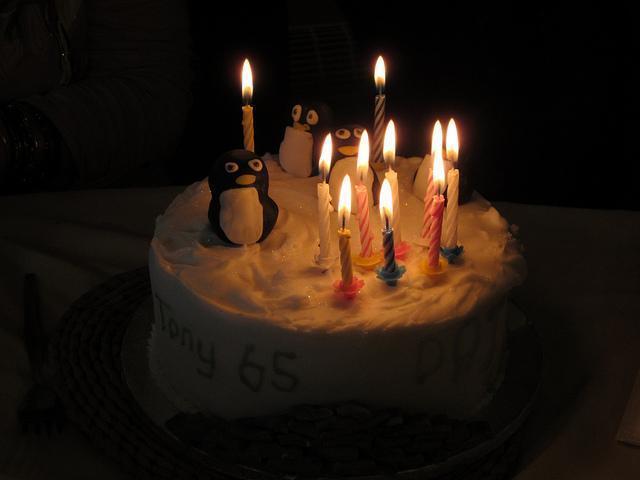How many candles are on the cake?
Give a very brief answer. 10. How many colors of candles are there?
Give a very brief answer. 4. How many candles are in this picture?
Give a very brief answer. 10. 